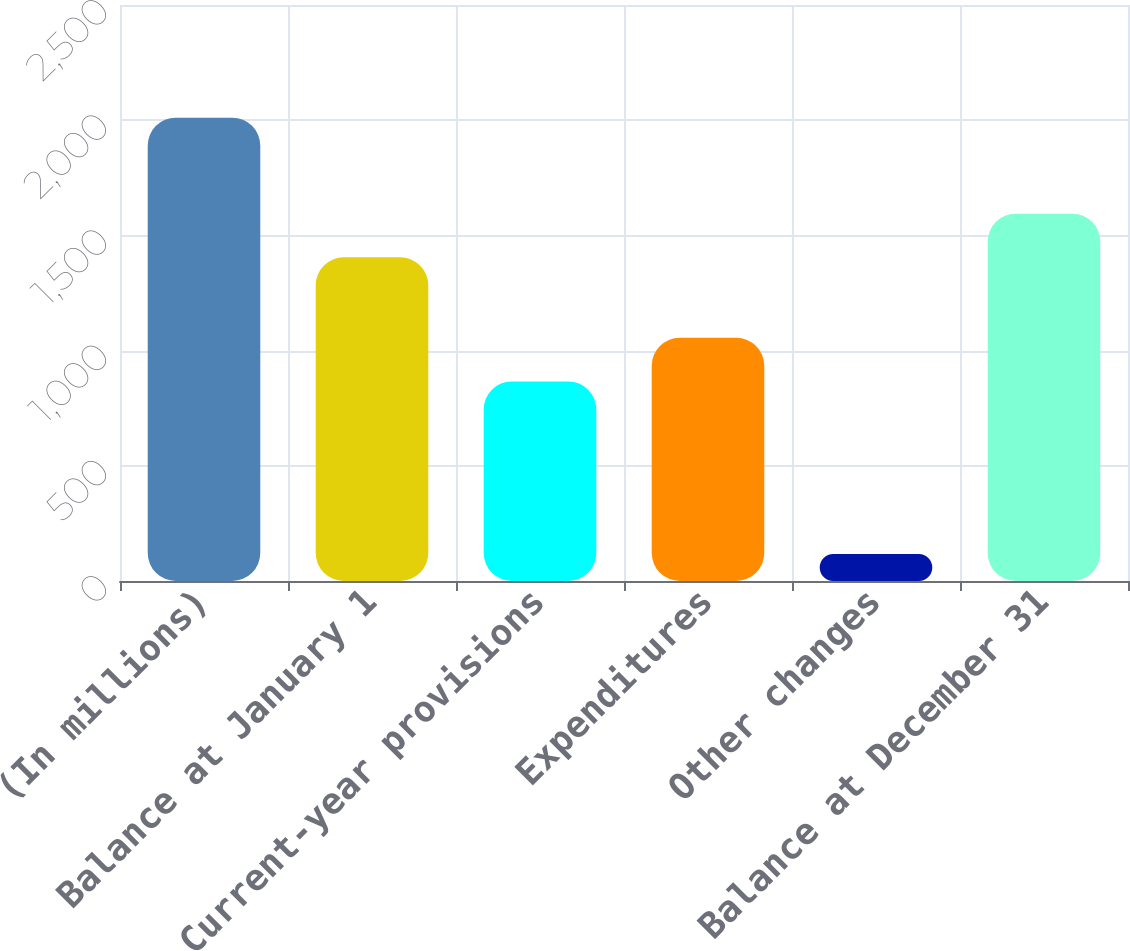<chart> <loc_0><loc_0><loc_500><loc_500><bar_chart><fcel>(In millions)<fcel>Balance at January 1<fcel>Current-year provisions<fcel>Expenditures<fcel>Other changes<fcel>Balance at December 31<nl><fcel>2011<fcel>1405<fcel>866<fcel>1055.4<fcel>117<fcel>1594.4<nl></chart> 